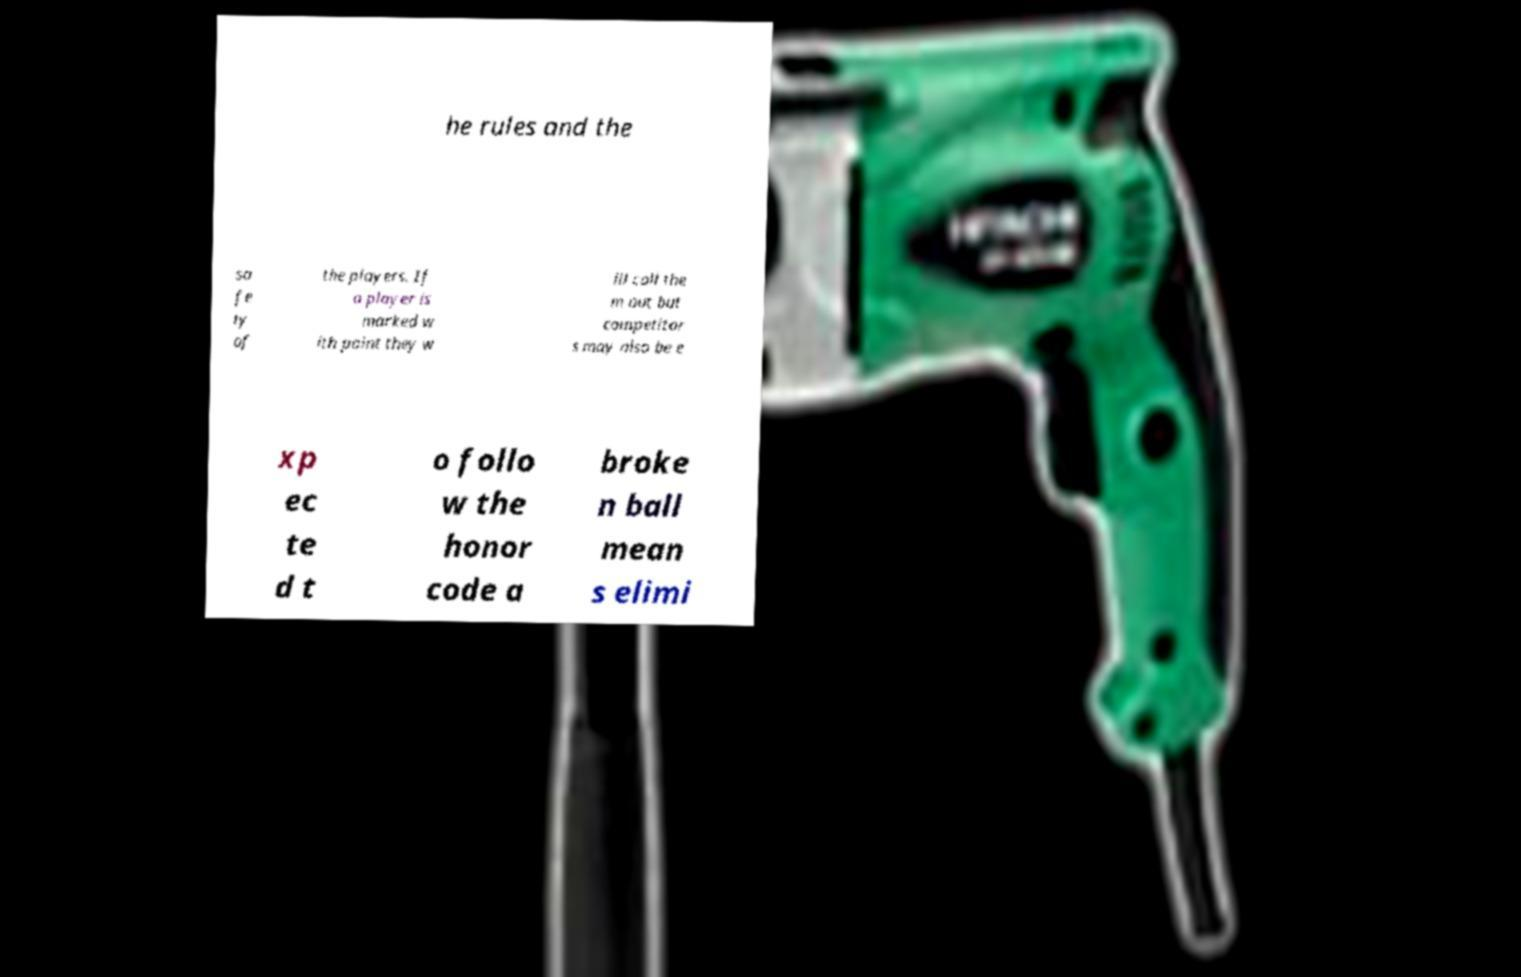There's text embedded in this image that I need extracted. Can you transcribe it verbatim? he rules and the sa fe ty of the players. If a player is marked w ith paint they w ill call the m out but competitor s may also be e xp ec te d t o follo w the honor code a broke n ball mean s elimi 